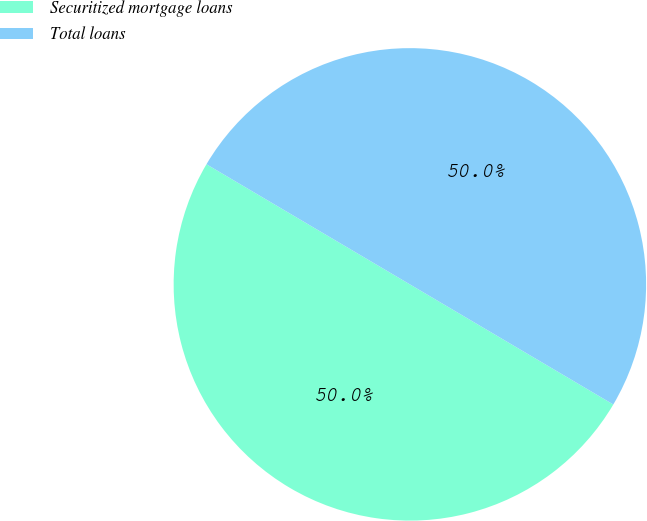Convert chart. <chart><loc_0><loc_0><loc_500><loc_500><pie_chart><fcel>Securitized mortgage loans<fcel>Total loans<nl><fcel>50.0%<fcel>50.0%<nl></chart> 